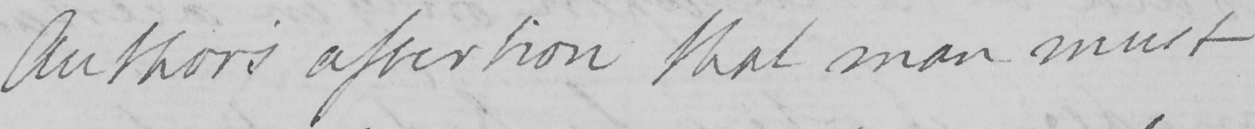What is written in this line of handwriting? Author ' s assertion that man must 